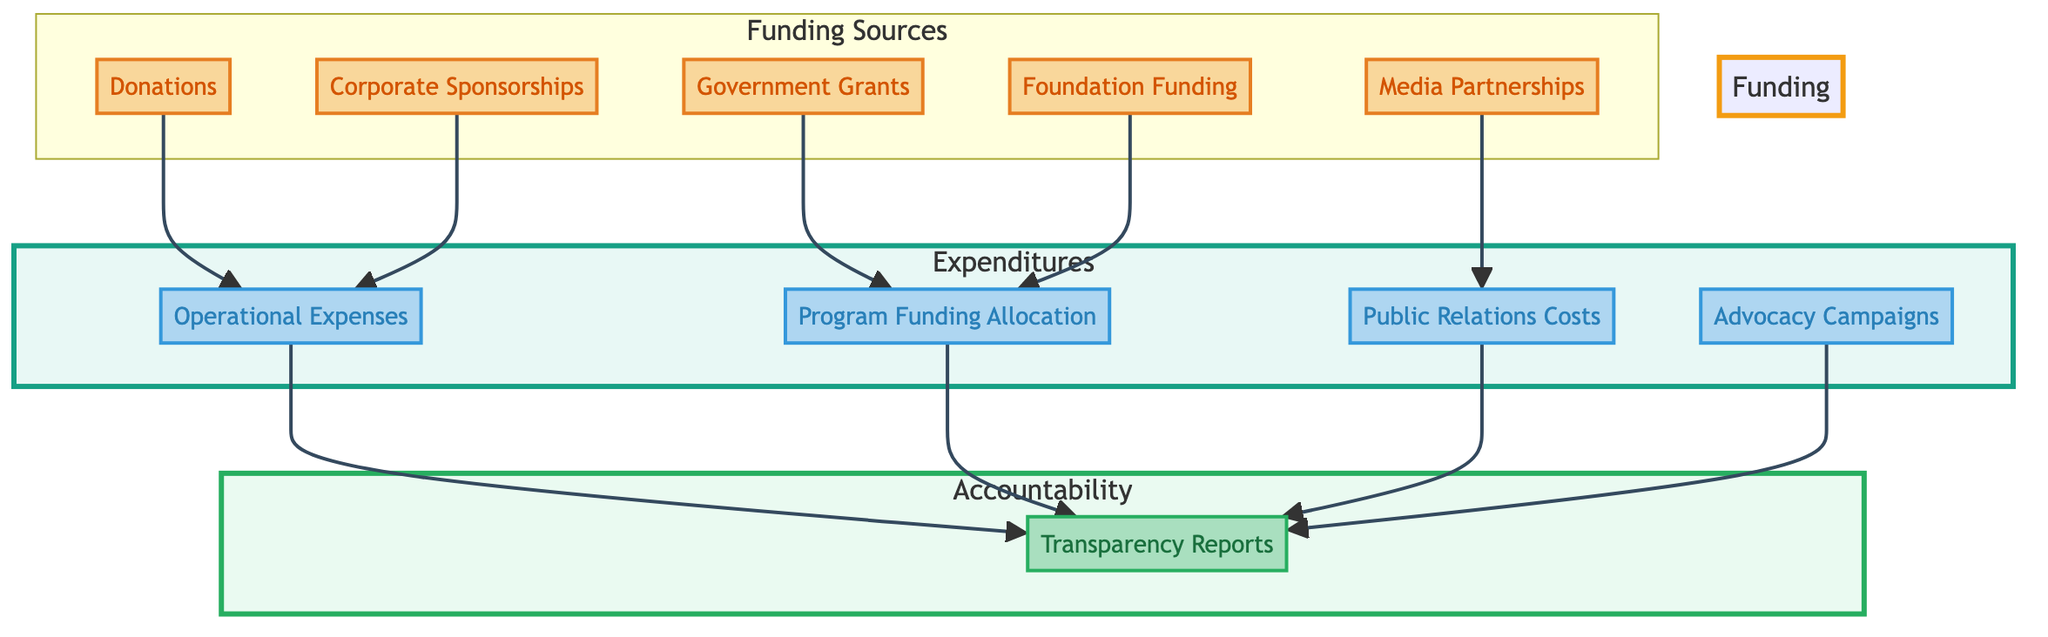What are the funding sources in the diagram? The funding sources in the diagram are Donations, Corporate Sponsorships, Government Grants, Foundation Funding, and Media Partnerships. Each of these nodes is connected to specific expenditures, indicating they are sources of funding for the nonprofit organization.
Answer: Donations, Corporate Sponsorships, Government Grants, Foundation Funding, Media Partnerships How many expenditures are shown in the diagram? The diagram shows four expenditures: Operational Expenses, Program Funding Allocation, Public Relations Costs, and Advocacy Campaigns. Each of these expenditures is linked to one or more funding sources, illustrating how funds are allocated.
Answer: Four Which source contributes to Operational Expenses? Donations and Corporate Sponsorships are the two sources contributing to Operational Expenses, as indicated by the arrows leading from each funding source directly to this expenditure.
Answer: Donations, Corporate Sponsorships What is the purpose of Transparency Reports? Transparency Reports serve to document and detail the funding sources and expenditures of the nonprofit organization, ensuring accountability by showing how funds are utilized and where they originate.
Answer: To document funding sources and expenditures Which expenditure is linked to both Government Grants and Foundation Funding? The Program Funding Allocation is linked to both Government Grants and Foundation Funding. This indicates that funds from these sources are specifically allocated for various programs and initiatives.
Answer: Program Funding Allocation How do Media Partnerships relate to expenditures in the diagram? Media Partnerships connect to Public Relations Costs in the diagram, illustrating that funding from media collaborations is allocated for PR campaigns and lobbying efforts related to the nonprofit organization.
Answer: Public Relations Costs How many components are grouped under 'Funding Sources'? There are five components grouped under 'Funding Sources': Donations, Corporate Sponsorships, Government Grants, Foundation Funding, and Media Partnerships. This categorization helps to identify the various means of funding the organization receives.
Answer: Five What type of expenses are Advocacy Campaigns categorized under? Advocacy Campaigns are categorized under expenditures in the diagram. They represent the financial resources allocated for lobbying and advocacy work by the nonprofit organization.
Answer: Expenditures Which sources flow into the Transparency Reports? The sources flowing into the Transparency Reports include Operational Expenses, Program Funding Allocation, Public Relations Costs, and Advocacy Campaigns. Each of these expenditures contributes to the overall documentation of funds and their usage.
Answer: Operational Expenses, Program Funding Allocation, Public Relations Costs, Advocacy Campaigns 